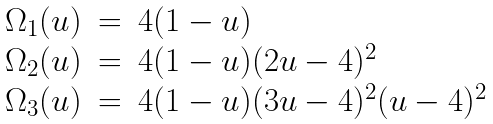<formula> <loc_0><loc_0><loc_500><loc_500>\begin{array} { l l l } \Omega _ { 1 } ( u ) & = & 4 ( 1 - u ) \\ \Omega _ { 2 } ( u ) & = & 4 ( 1 - u ) ( 2 u - 4 ) ^ { 2 } \\ \Omega _ { 3 } ( u ) & = & 4 ( 1 - u ) ( 3 u - 4 ) ^ { 2 } ( u - 4 ) ^ { 2 } \end{array}</formula> 